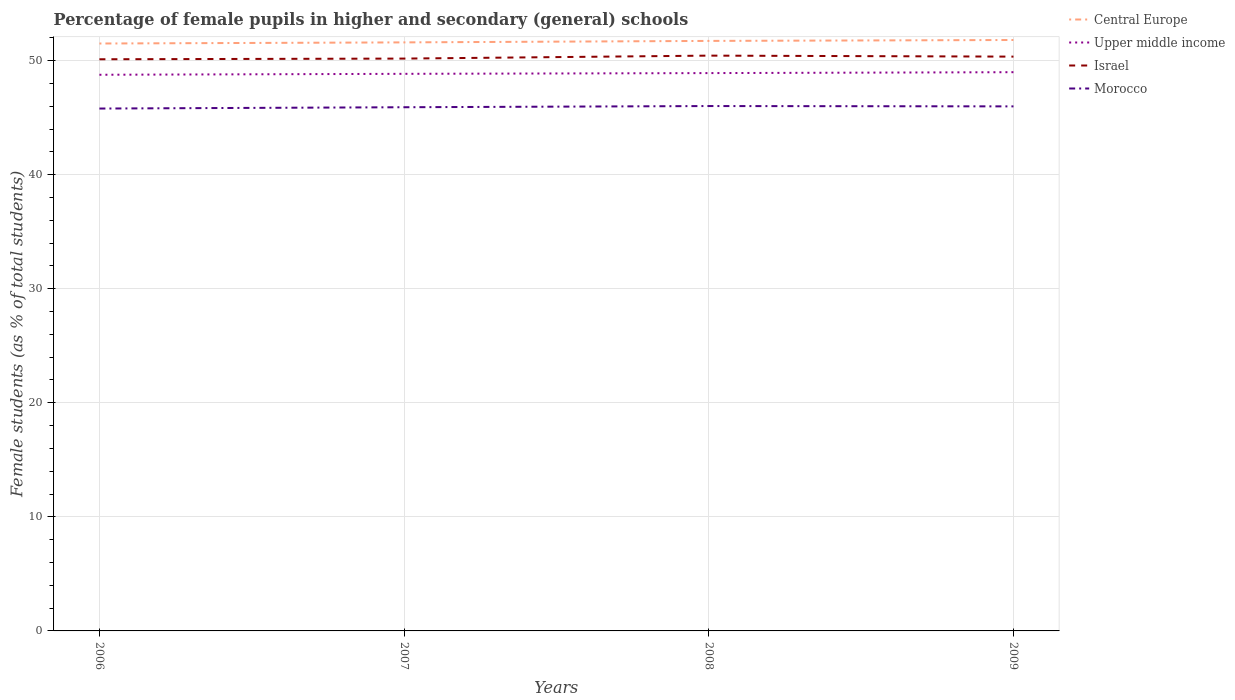Does the line corresponding to Central Europe intersect with the line corresponding to Morocco?
Provide a short and direct response. No. Across all years, what is the maximum percentage of female pupils in higher and secondary schools in Central Europe?
Your answer should be compact. 51.5. What is the total percentage of female pupils in higher and secondary schools in Morocco in the graph?
Your answer should be very brief. -0.22. What is the difference between the highest and the second highest percentage of female pupils in higher and secondary schools in Morocco?
Offer a very short reply. 0.22. How many years are there in the graph?
Ensure brevity in your answer.  4. Are the values on the major ticks of Y-axis written in scientific E-notation?
Offer a very short reply. No. Does the graph contain any zero values?
Your response must be concise. No. What is the title of the graph?
Your answer should be very brief. Percentage of female pupils in higher and secondary (general) schools. Does "Armenia" appear as one of the legend labels in the graph?
Give a very brief answer. No. What is the label or title of the X-axis?
Ensure brevity in your answer.  Years. What is the label or title of the Y-axis?
Your response must be concise. Female students (as % of total students). What is the Female students (as % of total students) of Central Europe in 2006?
Offer a very short reply. 51.5. What is the Female students (as % of total students) of Upper middle income in 2006?
Ensure brevity in your answer.  48.76. What is the Female students (as % of total students) of Israel in 2006?
Make the answer very short. 50.12. What is the Female students (as % of total students) in Morocco in 2006?
Offer a very short reply. 45.8. What is the Female students (as % of total students) in Central Europe in 2007?
Offer a terse response. 51.6. What is the Female students (as % of total students) of Upper middle income in 2007?
Ensure brevity in your answer.  48.84. What is the Female students (as % of total students) in Israel in 2007?
Your answer should be very brief. 50.18. What is the Female students (as % of total students) in Morocco in 2007?
Offer a very short reply. 45.91. What is the Female students (as % of total students) of Central Europe in 2008?
Offer a terse response. 51.73. What is the Female students (as % of total students) of Upper middle income in 2008?
Give a very brief answer. 48.91. What is the Female students (as % of total students) of Israel in 2008?
Offer a terse response. 50.44. What is the Female students (as % of total students) in Morocco in 2008?
Keep it short and to the point. 46.02. What is the Female students (as % of total students) in Central Europe in 2009?
Provide a succinct answer. 51.81. What is the Female students (as % of total students) in Upper middle income in 2009?
Provide a short and direct response. 48.99. What is the Female students (as % of total students) of Israel in 2009?
Keep it short and to the point. 50.35. What is the Female students (as % of total students) in Morocco in 2009?
Provide a succinct answer. 45.99. Across all years, what is the maximum Female students (as % of total students) in Central Europe?
Your answer should be very brief. 51.81. Across all years, what is the maximum Female students (as % of total students) of Upper middle income?
Keep it short and to the point. 48.99. Across all years, what is the maximum Female students (as % of total students) of Israel?
Your answer should be very brief. 50.44. Across all years, what is the maximum Female students (as % of total students) in Morocco?
Keep it short and to the point. 46.02. Across all years, what is the minimum Female students (as % of total students) of Central Europe?
Ensure brevity in your answer.  51.5. Across all years, what is the minimum Female students (as % of total students) in Upper middle income?
Give a very brief answer. 48.76. Across all years, what is the minimum Female students (as % of total students) in Israel?
Offer a very short reply. 50.12. Across all years, what is the minimum Female students (as % of total students) of Morocco?
Ensure brevity in your answer.  45.8. What is the total Female students (as % of total students) in Central Europe in the graph?
Your response must be concise. 206.63. What is the total Female students (as % of total students) in Upper middle income in the graph?
Your answer should be very brief. 195.49. What is the total Female students (as % of total students) in Israel in the graph?
Offer a terse response. 201.09. What is the total Female students (as % of total students) of Morocco in the graph?
Ensure brevity in your answer.  183.72. What is the difference between the Female students (as % of total students) in Central Europe in 2006 and that in 2007?
Make the answer very short. -0.1. What is the difference between the Female students (as % of total students) of Upper middle income in 2006 and that in 2007?
Offer a very short reply. -0.08. What is the difference between the Female students (as % of total students) in Israel in 2006 and that in 2007?
Offer a very short reply. -0.06. What is the difference between the Female students (as % of total students) of Morocco in 2006 and that in 2007?
Your answer should be compact. -0.12. What is the difference between the Female students (as % of total students) in Central Europe in 2006 and that in 2008?
Ensure brevity in your answer.  -0.23. What is the difference between the Female students (as % of total students) of Upper middle income in 2006 and that in 2008?
Give a very brief answer. -0.15. What is the difference between the Female students (as % of total students) of Israel in 2006 and that in 2008?
Offer a very short reply. -0.32. What is the difference between the Female students (as % of total students) of Morocco in 2006 and that in 2008?
Your response must be concise. -0.22. What is the difference between the Female students (as % of total students) in Central Europe in 2006 and that in 2009?
Offer a terse response. -0.31. What is the difference between the Female students (as % of total students) in Upper middle income in 2006 and that in 2009?
Keep it short and to the point. -0.23. What is the difference between the Female students (as % of total students) of Israel in 2006 and that in 2009?
Make the answer very short. -0.23. What is the difference between the Female students (as % of total students) of Morocco in 2006 and that in 2009?
Offer a very short reply. -0.19. What is the difference between the Female students (as % of total students) in Central Europe in 2007 and that in 2008?
Provide a short and direct response. -0.13. What is the difference between the Female students (as % of total students) of Upper middle income in 2007 and that in 2008?
Provide a succinct answer. -0.06. What is the difference between the Female students (as % of total students) in Israel in 2007 and that in 2008?
Offer a terse response. -0.26. What is the difference between the Female students (as % of total students) of Morocco in 2007 and that in 2008?
Ensure brevity in your answer.  -0.1. What is the difference between the Female students (as % of total students) in Central Europe in 2007 and that in 2009?
Give a very brief answer. -0.21. What is the difference between the Female students (as % of total students) of Upper middle income in 2007 and that in 2009?
Your response must be concise. -0.14. What is the difference between the Female students (as % of total students) in Israel in 2007 and that in 2009?
Offer a terse response. -0.17. What is the difference between the Female students (as % of total students) of Morocco in 2007 and that in 2009?
Keep it short and to the point. -0.07. What is the difference between the Female students (as % of total students) of Central Europe in 2008 and that in 2009?
Your answer should be compact. -0.08. What is the difference between the Female students (as % of total students) of Upper middle income in 2008 and that in 2009?
Offer a terse response. -0.08. What is the difference between the Female students (as % of total students) of Israel in 2008 and that in 2009?
Your response must be concise. 0.09. What is the difference between the Female students (as % of total students) in Morocco in 2008 and that in 2009?
Your response must be concise. 0.03. What is the difference between the Female students (as % of total students) in Central Europe in 2006 and the Female students (as % of total students) in Upper middle income in 2007?
Your answer should be very brief. 2.66. What is the difference between the Female students (as % of total students) of Central Europe in 2006 and the Female students (as % of total students) of Israel in 2007?
Give a very brief answer. 1.32. What is the difference between the Female students (as % of total students) in Central Europe in 2006 and the Female students (as % of total students) in Morocco in 2007?
Offer a very short reply. 5.59. What is the difference between the Female students (as % of total students) of Upper middle income in 2006 and the Female students (as % of total students) of Israel in 2007?
Offer a terse response. -1.42. What is the difference between the Female students (as % of total students) in Upper middle income in 2006 and the Female students (as % of total students) in Morocco in 2007?
Provide a short and direct response. 2.85. What is the difference between the Female students (as % of total students) in Israel in 2006 and the Female students (as % of total students) in Morocco in 2007?
Your answer should be very brief. 4.21. What is the difference between the Female students (as % of total students) of Central Europe in 2006 and the Female students (as % of total students) of Upper middle income in 2008?
Provide a short and direct response. 2.59. What is the difference between the Female students (as % of total students) in Central Europe in 2006 and the Female students (as % of total students) in Israel in 2008?
Your answer should be compact. 1.06. What is the difference between the Female students (as % of total students) in Central Europe in 2006 and the Female students (as % of total students) in Morocco in 2008?
Offer a very short reply. 5.48. What is the difference between the Female students (as % of total students) of Upper middle income in 2006 and the Female students (as % of total students) of Israel in 2008?
Offer a terse response. -1.68. What is the difference between the Female students (as % of total students) in Upper middle income in 2006 and the Female students (as % of total students) in Morocco in 2008?
Your answer should be very brief. 2.74. What is the difference between the Female students (as % of total students) in Israel in 2006 and the Female students (as % of total students) in Morocco in 2008?
Give a very brief answer. 4.1. What is the difference between the Female students (as % of total students) of Central Europe in 2006 and the Female students (as % of total students) of Upper middle income in 2009?
Offer a very short reply. 2.51. What is the difference between the Female students (as % of total students) in Central Europe in 2006 and the Female students (as % of total students) in Israel in 2009?
Ensure brevity in your answer.  1.15. What is the difference between the Female students (as % of total students) of Central Europe in 2006 and the Female students (as % of total students) of Morocco in 2009?
Provide a short and direct response. 5.51. What is the difference between the Female students (as % of total students) of Upper middle income in 2006 and the Female students (as % of total students) of Israel in 2009?
Provide a succinct answer. -1.59. What is the difference between the Female students (as % of total students) of Upper middle income in 2006 and the Female students (as % of total students) of Morocco in 2009?
Ensure brevity in your answer.  2.77. What is the difference between the Female students (as % of total students) in Israel in 2006 and the Female students (as % of total students) in Morocco in 2009?
Provide a short and direct response. 4.13. What is the difference between the Female students (as % of total students) of Central Europe in 2007 and the Female students (as % of total students) of Upper middle income in 2008?
Provide a short and direct response. 2.69. What is the difference between the Female students (as % of total students) in Central Europe in 2007 and the Female students (as % of total students) in Israel in 2008?
Your response must be concise. 1.16. What is the difference between the Female students (as % of total students) of Central Europe in 2007 and the Female students (as % of total students) of Morocco in 2008?
Give a very brief answer. 5.58. What is the difference between the Female students (as % of total students) of Upper middle income in 2007 and the Female students (as % of total students) of Israel in 2008?
Provide a succinct answer. -1.6. What is the difference between the Female students (as % of total students) in Upper middle income in 2007 and the Female students (as % of total students) in Morocco in 2008?
Your answer should be compact. 2.82. What is the difference between the Female students (as % of total students) in Israel in 2007 and the Female students (as % of total students) in Morocco in 2008?
Your answer should be very brief. 4.16. What is the difference between the Female students (as % of total students) in Central Europe in 2007 and the Female students (as % of total students) in Upper middle income in 2009?
Provide a succinct answer. 2.61. What is the difference between the Female students (as % of total students) in Central Europe in 2007 and the Female students (as % of total students) in Israel in 2009?
Ensure brevity in your answer.  1.25. What is the difference between the Female students (as % of total students) of Central Europe in 2007 and the Female students (as % of total students) of Morocco in 2009?
Keep it short and to the point. 5.61. What is the difference between the Female students (as % of total students) in Upper middle income in 2007 and the Female students (as % of total students) in Israel in 2009?
Provide a short and direct response. -1.51. What is the difference between the Female students (as % of total students) of Upper middle income in 2007 and the Female students (as % of total students) of Morocco in 2009?
Offer a terse response. 2.85. What is the difference between the Female students (as % of total students) of Israel in 2007 and the Female students (as % of total students) of Morocco in 2009?
Provide a succinct answer. 4.19. What is the difference between the Female students (as % of total students) in Central Europe in 2008 and the Female students (as % of total students) in Upper middle income in 2009?
Your answer should be very brief. 2.74. What is the difference between the Female students (as % of total students) in Central Europe in 2008 and the Female students (as % of total students) in Israel in 2009?
Your answer should be compact. 1.38. What is the difference between the Female students (as % of total students) in Central Europe in 2008 and the Female students (as % of total students) in Morocco in 2009?
Keep it short and to the point. 5.74. What is the difference between the Female students (as % of total students) of Upper middle income in 2008 and the Female students (as % of total students) of Israel in 2009?
Provide a succinct answer. -1.44. What is the difference between the Female students (as % of total students) in Upper middle income in 2008 and the Female students (as % of total students) in Morocco in 2009?
Give a very brief answer. 2.92. What is the difference between the Female students (as % of total students) of Israel in 2008 and the Female students (as % of total students) of Morocco in 2009?
Offer a terse response. 4.45. What is the average Female students (as % of total students) in Central Europe per year?
Your answer should be compact. 51.66. What is the average Female students (as % of total students) of Upper middle income per year?
Keep it short and to the point. 48.87. What is the average Female students (as % of total students) in Israel per year?
Make the answer very short. 50.27. What is the average Female students (as % of total students) of Morocco per year?
Offer a very short reply. 45.93. In the year 2006, what is the difference between the Female students (as % of total students) in Central Europe and Female students (as % of total students) in Upper middle income?
Provide a succinct answer. 2.74. In the year 2006, what is the difference between the Female students (as % of total students) of Central Europe and Female students (as % of total students) of Israel?
Keep it short and to the point. 1.38. In the year 2006, what is the difference between the Female students (as % of total students) in Central Europe and Female students (as % of total students) in Morocco?
Your answer should be compact. 5.7. In the year 2006, what is the difference between the Female students (as % of total students) in Upper middle income and Female students (as % of total students) in Israel?
Offer a very short reply. -1.36. In the year 2006, what is the difference between the Female students (as % of total students) of Upper middle income and Female students (as % of total students) of Morocco?
Your answer should be very brief. 2.96. In the year 2006, what is the difference between the Female students (as % of total students) in Israel and Female students (as % of total students) in Morocco?
Offer a very short reply. 4.32. In the year 2007, what is the difference between the Female students (as % of total students) of Central Europe and Female students (as % of total students) of Upper middle income?
Your response must be concise. 2.76. In the year 2007, what is the difference between the Female students (as % of total students) of Central Europe and Female students (as % of total students) of Israel?
Provide a succinct answer. 1.42. In the year 2007, what is the difference between the Female students (as % of total students) of Central Europe and Female students (as % of total students) of Morocco?
Your answer should be very brief. 5.69. In the year 2007, what is the difference between the Female students (as % of total students) in Upper middle income and Female students (as % of total students) in Israel?
Provide a short and direct response. -1.34. In the year 2007, what is the difference between the Female students (as % of total students) in Upper middle income and Female students (as % of total students) in Morocco?
Give a very brief answer. 2.93. In the year 2007, what is the difference between the Female students (as % of total students) of Israel and Female students (as % of total students) of Morocco?
Ensure brevity in your answer.  4.27. In the year 2008, what is the difference between the Female students (as % of total students) in Central Europe and Female students (as % of total students) in Upper middle income?
Your response must be concise. 2.82. In the year 2008, what is the difference between the Female students (as % of total students) in Central Europe and Female students (as % of total students) in Israel?
Your answer should be very brief. 1.29. In the year 2008, what is the difference between the Female students (as % of total students) of Central Europe and Female students (as % of total students) of Morocco?
Give a very brief answer. 5.71. In the year 2008, what is the difference between the Female students (as % of total students) of Upper middle income and Female students (as % of total students) of Israel?
Give a very brief answer. -1.53. In the year 2008, what is the difference between the Female students (as % of total students) of Upper middle income and Female students (as % of total students) of Morocco?
Give a very brief answer. 2.89. In the year 2008, what is the difference between the Female students (as % of total students) in Israel and Female students (as % of total students) in Morocco?
Your answer should be very brief. 4.42. In the year 2009, what is the difference between the Female students (as % of total students) in Central Europe and Female students (as % of total students) in Upper middle income?
Offer a terse response. 2.82. In the year 2009, what is the difference between the Female students (as % of total students) in Central Europe and Female students (as % of total students) in Israel?
Make the answer very short. 1.46. In the year 2009, what is the difference between the Female students (as % of total students) in Central Europe and Female students (as % of total students) in Morocco?
Make the answer very short. 5.82. In the year 2009, what is the difference between the Female students (as % of total students) in Upper middle income and Female students (as % of total students) in Israel?
Provide a succinct answer. -1.36. In the year 2009, what is the difference between the Female students (as % of total students) in Upper middle income and Female students (as % of total students) in Morocco?
Provide a succinct answer. 3. In the year 2009, what is the difference between the Female students (as % of total students) of Israel and Female students (as % of total students) of Morocco?
Give a very brief answer. 4.36. What is the ratio of the Female students (as % of total students) in Upper middle income in 2006 to that in 2008?
Your response must be concise. 1. What is the ratio of the Female students (as % of total students) in Israel in 2006 to that in 2008?
Offer a terse response. 0.99. What is the ratio of the Female students (as % of total students) in Upper middle income in 2006 to that in 2009?
Your response must be concise. 1. What is the ratio of the Female students (as % of total students) in Israel in 2006 to that in 2009?
Keep it short and to the point. 1. What is the ratio of the Female students (as % of total students) in Upper middle income in 2007 to that in 2008?
Offer a very short reply. 1. What is the ratio of the Female students (as % of total students) in Upper middle income in 2007 to that in 2009?
Give a very brief answer. 1. What is the ratio of the Female students (as % of total students) in Morocco in 2007 to that in 2009?
Your answer should be compact. 1. What is the ratio of the Female students (as % of total students) in Israel in 2008 to that in 2009?
Your response must be concise. 1. What is the difference between the highest and the second highest Female students (as % of total students) in Central Europe?
Make the answer very short. 0.08. What is the difference between the highest and the second highest Female students (as % of total students) in Upper middle income?
Offer a terse response. 0.08. What is the difference between the highest and the second highest Female students (as % of total students) in Israel?
Provide a short and direct response. 0.09. What is the difference between the highest and the second highest Female students (as % of total students) of Morocco?
Give a very brief answer. 0.03. What is the difference between the highest and the lowest Female students (as % of total students) in Central Europe?
Offer a very short reply. 0.31. What is the difference between the highest and the lowest Female students (as % of total students) of Upper middle income?
Your response must be concise. 0.23. What is the difference between the highest and the lowest Female students (as % of total students) of Israel?
Keep it short and to the point. 0.32. What is the difference between the highest and the lowest Female students (as % of total students) of Morocco?
Your answer should be very brief. 0.22. 